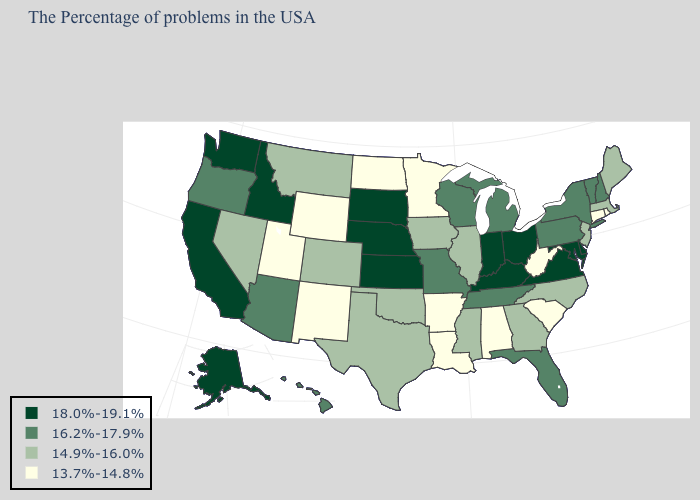How many symbols are there in the legend?
Write a very short answer. 4. Among the states that border Indiana , which have the lowest value?
Give a very brief answer. Illinois. What is the value of Connecticut?
Write a very short answer. 13.7%-14.8%. Does the first symbol in the legend represent the smallest category?
Keep it brief. No. Does the map have missing data?
Quick response, please. No. Does Connecticut have the lowest value in the Northeast?
Give a very brief answer. Yes. How many symbols are there in the legend?
Give a very brief answer. 4. What is the highest value in the MidWest ?
Keep it brief. 18.0%-19.1%. Among the states that border Virginia , does West Virginia have the lowest value?
Quick response, please. Yes. Which states have the lowest value in the West?
Give a very brief answer. Wyoming, New Mexico, Utah. What is the value of Connecticut?
Give a very brief answer. 13.7%-14.8%. Name the states that have a value in the range 16.2%-17.9%?
Short answer required. New Hampshire, Vermont, New York, Pennsylvania, Florida, Michigan, Tennessee, Wisconsin, Missouri, Arizona, Oregon, Hawaii. What is the lowest value in states that border Pennsylvania?
Short answer required. 13.7%-14.8%. Which states hav the highest value in the Northeast?
Give a very brief answer. New Hampshire, Vermont, New York, Pennsylvania. Does the first symbol in the legend represent the smallest category?
Keep it brief. No. 